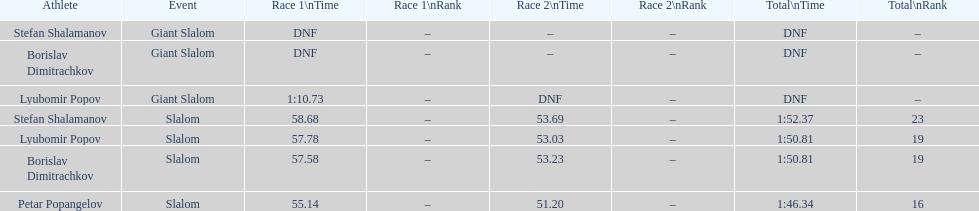What is the difference in time for petar popangelov in race 1and 2 3.94. 